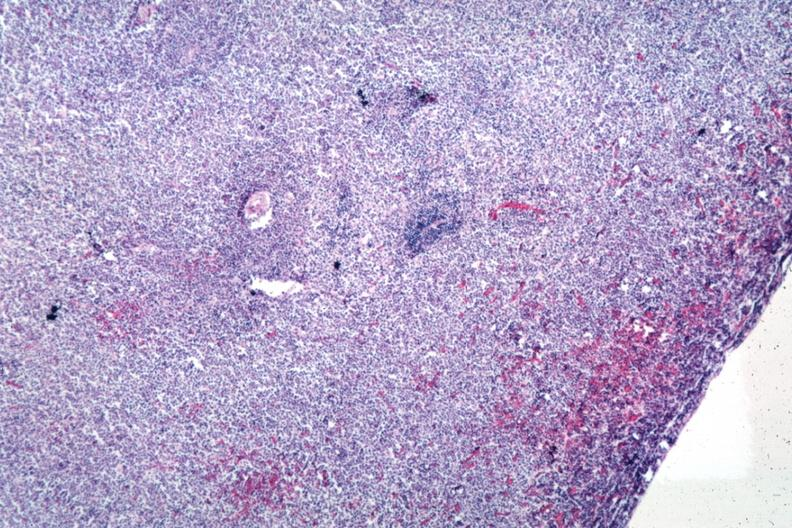s hematologic present?
Answer the question using a single word or phrase. Yes 